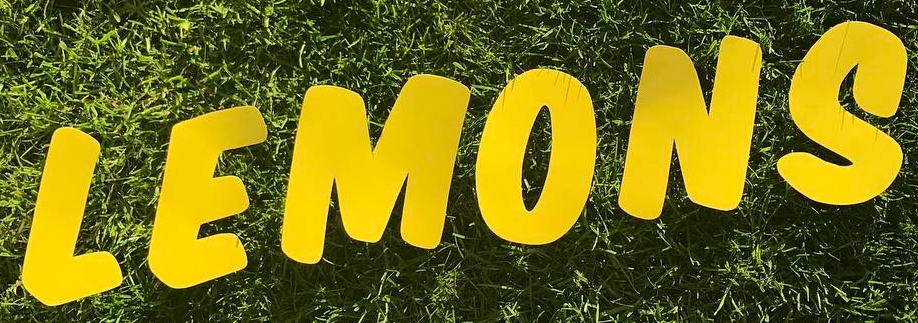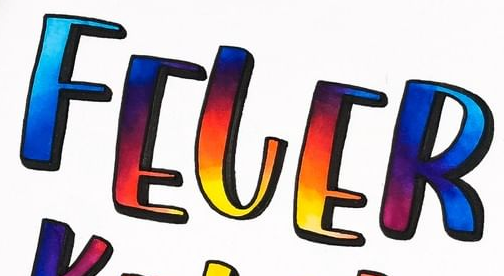Identify the words shown in these images in order, separated by a semicolon. LEMONS; FELER 